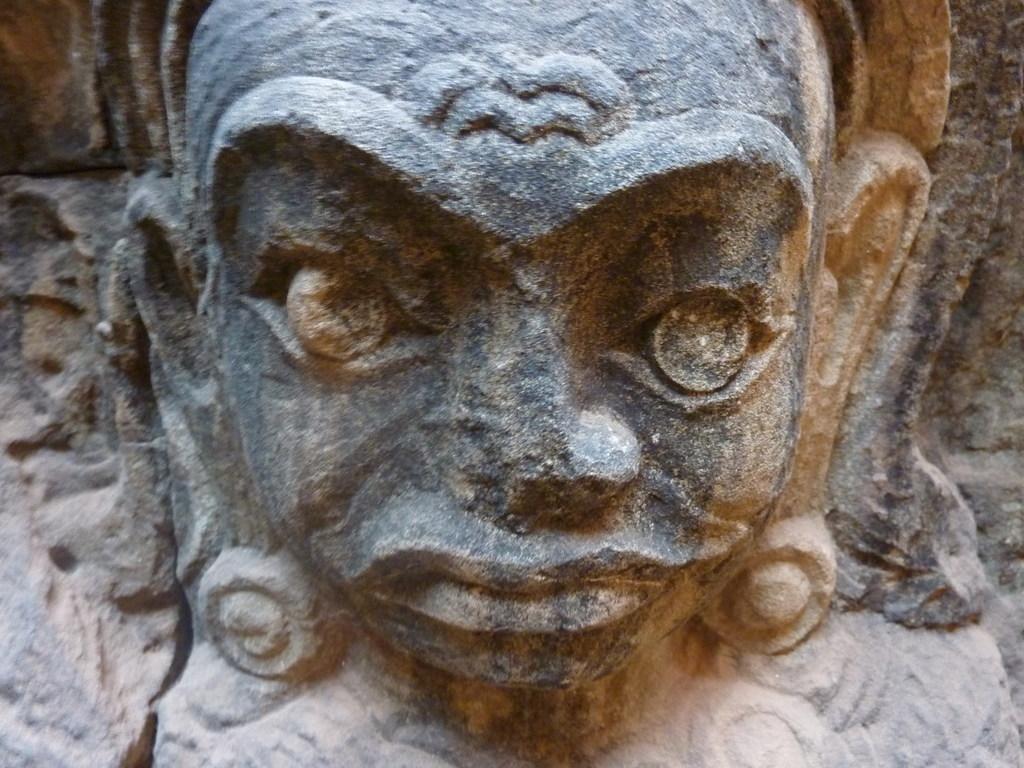Could you give a brief overview of what you see in this image? In this image we can see a sculpture to the wall. 